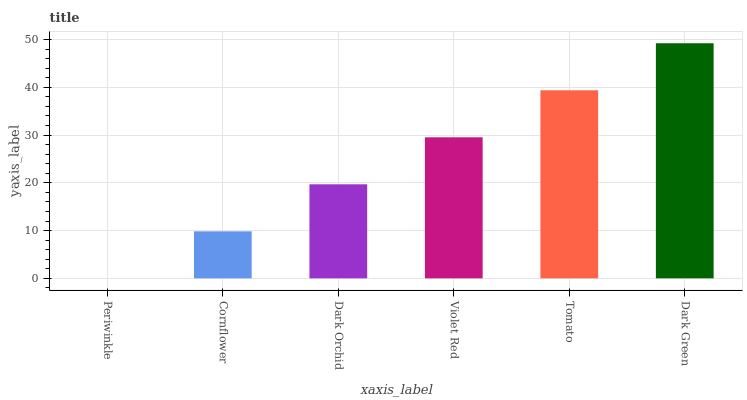Is Periwinkle the minimum?
Answer yes or no. Yes. Is Dark Green the maximum?
Answer yes or no. Yes. Is Cornflower the minimum?
Answer yes or no. No. Is Cornflower the maximum?
Answer yes or no. No. Is Cornflower greater than Periwinkle?
Answer yes or no. Yes. Is Periwinkle less than Cornflower?
Answer yes or no. Yes. Is Periwinkle greater than Cornflower?
Answer yes or no. No. Is Cornflower less than Periwinkle?
Answer yes or no. No. Is Violet Red the high median?
Answer yes or no. Yes. Is Dark Orchid the low median?
Answer yes or no. Yes. Is Dark Green the high median?
Answer yes or no. No. Is Dark Green the low median?
Answer yes or no. No. 